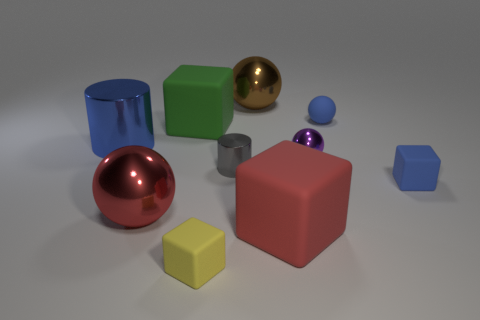How many things are the same color as the big cylinder?
Your answer should be very brief. 2. There is a red object that is on the right side of the large brown thing; what size is it?
Offer a terse response. Large. There is a metallic cylinder that is the same color as the tiny matte ball; what is its size?
Provide a succinct answer. Large. Do the green rubber thing and the metal object that is right of the brown thing have the same size?
Give a very brief answer. No. There is a large cylinder; is its color the same as the tiny thing that is behind the blue cylinder?
Give a very brief answer. Yes. Is there anything else that is the same color as the rubber sphere?
Ensure brevity in your answer.  Yes. Do the brown thing and the tiny blue object that is behind the green matte thing have the same material?
Your response must be concise. No. How many objects are either big rubber objects that are in front of the purple thing or small purple metallic blocks?
Provide a succinct answer. 1. Is there a matte thing that has the same color as the matte ball?
Give a very brief answer. Yes. Does the green thing have the same shape as the large red metallic object to the right of the large blue cylinder?
Your answer should be very brief. No. 